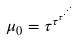Convert formula to latex. <formula><loc_0><loc_0><loc_500><loc_500>\mu _ { 0 } = \tau ^ { \tau ^ { \tau ^ { \cdot ^ { \cdot ^ { \cdot } } } } }</formula> 